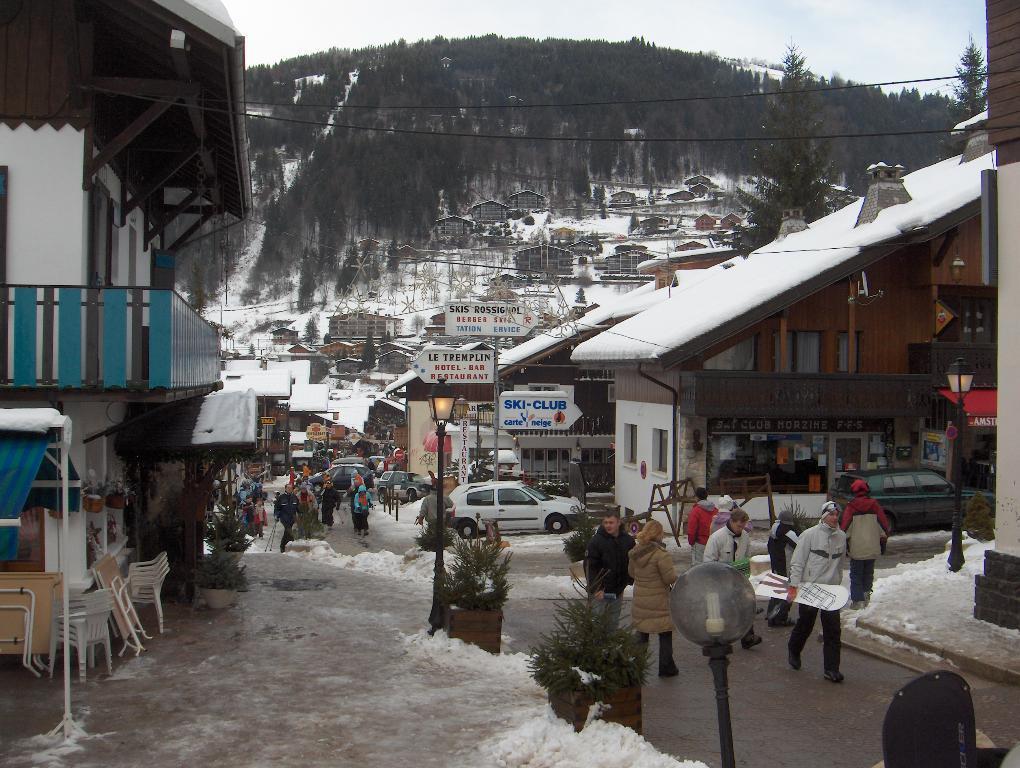Please provide a concise description of this image. In this picture we can see open market. In the front we can see some people walking on the road. On the left we can see snow on the ground. Behind we can see some shed houses and shops. On the top we can see huge mountain full of trees. 